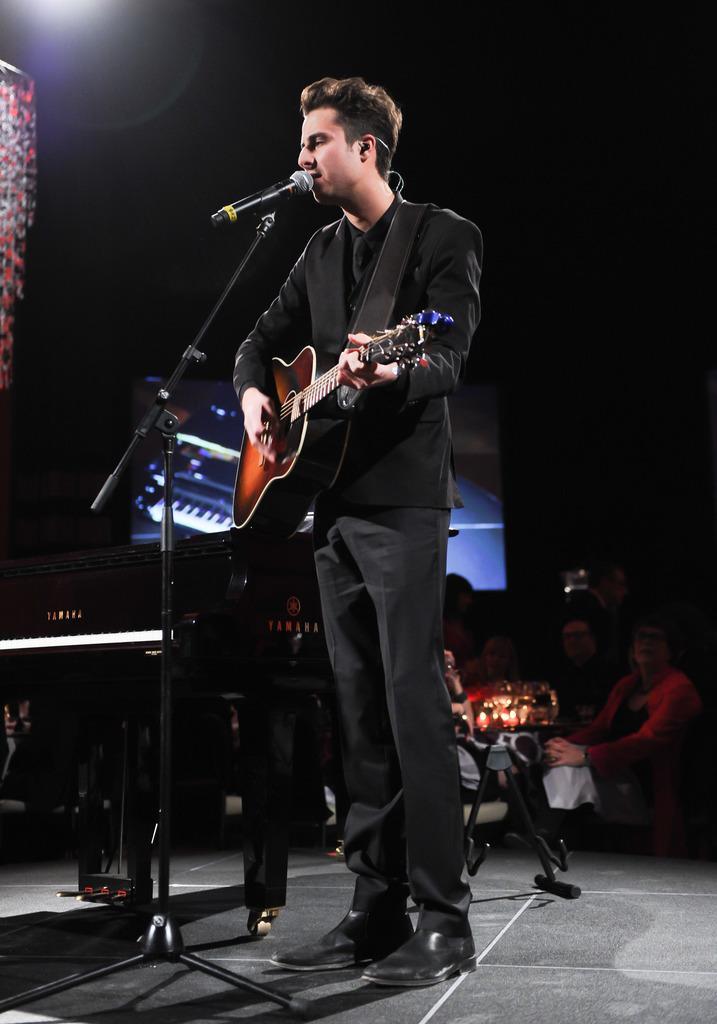Can you describe this image briefly? This man wore black suit and playing a guitar in-front of mic. This is a mic holder. Far these persons are sitting. This is a piano keyboard. A screen on wall. 